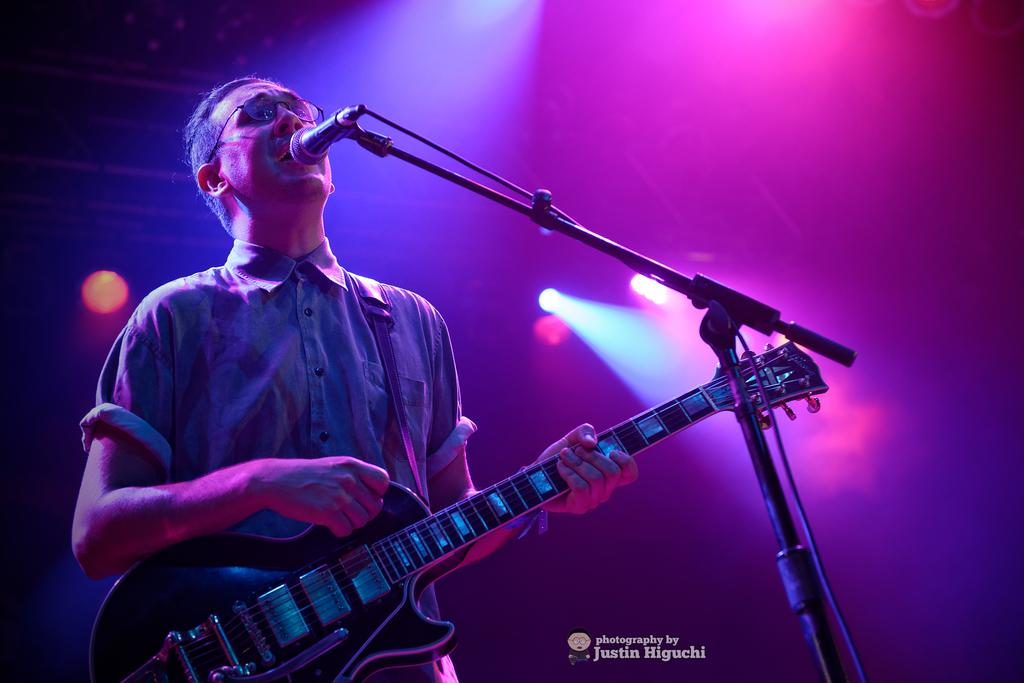What is the man in the image doing? The man is standing and playing a guitar. What is the man wearing in the image? The man is wearing a blue shirt and spectacles. What object is in front of the man? There is a microphone in front of the man. What can be seen to the left side of the man? There are lights to the left side of the man. What type of oil is being used to lubricate the quill in the image? There is no oil or quill present in the image; it features a man playing a guitar with a microphone in front of him. 